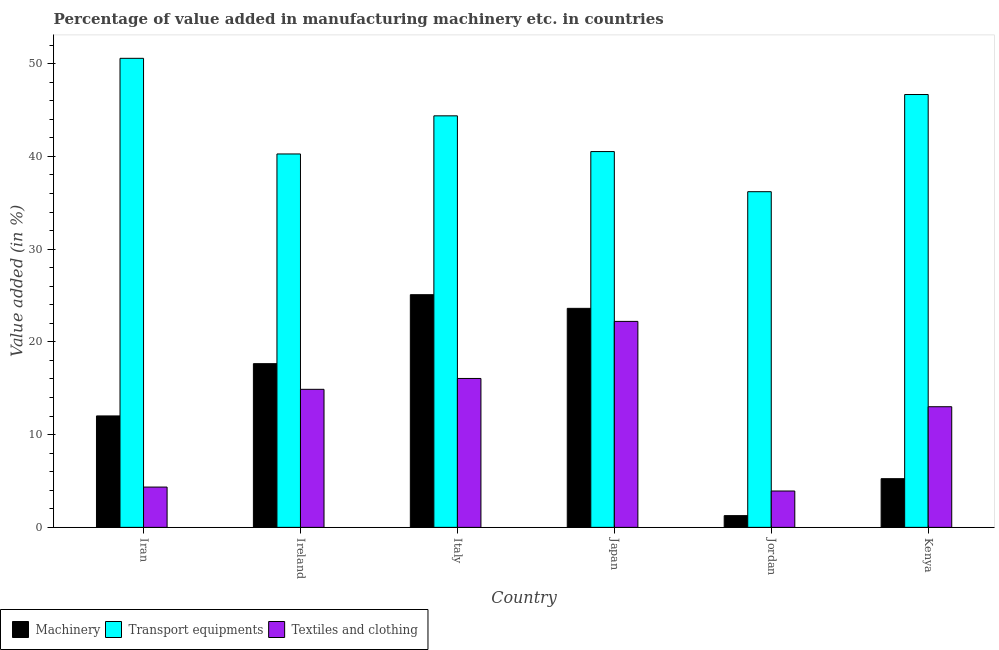How many groups of bars are there?
Give a very brief answer. 6. Are the number of bars per tick equal to the number of legend labels?
Provide a succinct answer. Yes. Are the number of bars on each tick of the X-axis equal?
Offer a terse response. Yes. What is the label of the 6th group of bars from the left?
Keep it short and to the point. Kenya. In how many cases, is the number of bars for a given country not equal to the number of legend labels?
Make the answer very short. 0. What is the value added in manufacturing textile and clothing in Kenya?
Make the answer very short. 13.01. Across all countries, what is the maximum value added in manufacturing transport equipments?
Offer a very short reply. 50.57. Across all countries, what is the minimum value added in manufacturing textile and clothing?
Give a very brief answer. 3.92. In which country was the value added in manufacturing machinery minimum?
Offer a very short reply. Jordan. What is the total value added in manufacturing textile and clothing in the graph?
Offer a terse response. 74.42. What is the difference between the value added in manufacturing machinery in Japan and that in Kenya?
Ensure brevity in your answer.  18.37. What is the difference between the value added in manufacturing machinery in Kenya and the value added in manufacturing transport equipments in Italy?
Provide a short and direct response. -39.12. What is the average value added in manufacturing transport equipments per country?
Provide a succinct answer. 43.1. What is the difference between the value added in manufacturing machinery and value added in manufacturing textile and clothing in Ireland?
Offer a very short reply. 2.77. In how many countries, is the value added in manufacturing machinery greater than 40 %?
Offer a terse response. 0. What is the ratio of the value added in manufacturing textile and clothing in Ireland to that in Kenya?
Give a very brief answer. 1.14. Is the difference between the value added in manufacturing transport equipments in Ireland and Jordan greater than the difference between the value added in manufacturing machinery in Ireland and Jordan?
Your response must be concise. No. What is the difference between the highest and the second highest value added in manufacturing machinery?
Your response must be concise. 1.47. What is the difference between the highest and the lowest value added in manufacturing machinery?
Provide a succinct answer. 23.82. In how many countries, is the value added in manufacturing machinery greater than the average value added in manufacturing machinery taken over all countries?
Provide a short and direct response. 3. Is the sum of the value added in manufacturing machinery in Ireland and Italy greater than the maximum value added in manufacturing transport equipments across all countries?
Provide a short and direct response. No. What does the 2nd bar from the left in Italy represents?
Your answer should be very brief. Transport equipments. What does the 1st bar from the right in Italy represents?
Offer a very short reply. Textiles and clothing. Is it the case that in every country, the sum of the value added in manufacturing machinery and value added in manufacturing transport equipments is greater than the value added in manufacturing textile and clothing?
Ensure brevity in your answer.  Yes. Are all the bars in the graph horizontal?
Ensure brevity in your answer.  No. How many countries are there in the graph?
Your answer should be very brief. 6. What is the difference between two consecutive major ticks on the Y-axis?
Offer a terse response. 10. Are the values on the major ticks of Y-axis written in scientific E-notation?
Your response must be concise. No. Does the graph contain any zero values?
Make the answer very short. No. Where does the legend appear in the graph?
Ensure brevity in your answer.  Bottom left. How many legend labels are there?
Make the answer very short. 3. How are the legend labels stacked?
Keep it short and to the point. Horizontal. What is the title of the graph?
Offer a terse response. Percentage of value added in manufacturing machinery etc. in countries. Does "Food" appear as one of the legend labels in the graph?
Your response must be concise. No. What is the label or title of the X-axis?
Offer a terse response. Country. What is the label or title of the Y-axis?
Your answer should be very brief. Value added (in %). What is the Value added (in %) of Machinery in Iran?
Offer a terse response. 12.01. What is the Value added (in %) of Transport equipments in Iran?
Make the answer very short. 50.57. What is the Value added (in %) of Textiles and clothing in Iran?
Ensure brevity in your answer.  4.34. What is the Value added (in %) in Machinery in Ireland?
Your answer should be compact. 17.65. What is the Value added (in %) of Transport equipments in Ireland?
Keep it short and to the point. 40.26. What is the Value added (in %) in Textiles and clothing in Ireland?
Give a very brief answer. 14.88. What is the Value added (in %) of Machinery in Italy?
Your answer should be very brief. 25.09. What is the Value added (in %) of Transport equipments in Italy?
Your answer should be very brief. 44.37. What is the Value added (in %) in Textiles and clothing in Italy?
Offer a terse response. 16.06. What is the Value added (in %) in Machinery in Japan?
Your answer should be compact. 23.61. What is the Value added (in %) of Transport equipments in Japan?
Your answer should be compact. 40.52. What is the Value added (in %) in Textiles and clothing in Japan?
Offer a terse response. 22.21. What is the Value added (in %) of Machinery in Jordan?
Your answer should be compact. 1.26. What is the Value added (in %) in Transport equipments in Jordan?
Provide a short and direct response. 36.19. What is the Value added (in %) of Textiles and clothing in Jordan?
Ensure brevity in your answer.  3.92. What is the Value added (in %) of Machinery in Kenya?
Your answer should be very brief. 5.25. What is the Value added (in %) in Transport equipments in Kenya?
Your answer should be very brief. 46.67. What is the Value added (in %) of Textiles and clothing in Kenya?
Keep it short and to the point. 13.01. Across all countries, what is the maximum Value added (in %) in Machinery?
Provide a short and direct response. 25.09. Across all countries, what is the maximum Value added (in %) of Transport equipments?
Make the answer very short. 50.57. Across all countries, what is the maximum Value added (in %) in Textiles and clothing?
Your answer should be very brief. 22.21. Across all countries, what is the minimum Value added (in %) in Machinery?
Ensure brevity in your answer.  1.26. Across all countries, what is the minimum Value added (in %) in Transport equipments?
Provide a short and direct response. 36.19. Across all countries, what is the minimum Value added (in %) in Textiles and clothing?
Your answer should be very brief. 3.92. What is the total Value added (in %) of Machinery in the graph?
Keep it short and to the point. 84.88. What is the total Value added (in %) in Transport equipments in the graph?
Provide a short and direct response. 258.59. What is the total Value added (in %) of Textiles and clothing in the graph?
Ensure brevity in your answer.  74.42. What is the difference between the Value added (in %) in Machinery in Iran and that in Ireland?
Ensure brevity in your answer.  -5.64. What is the difference between the Value added (in %) of Transport equipments in Iran and that in Ireland?
Provide a succinct answer. 10.31. What is the difference between the Value added (in %) in Textiles and clothing in Iran and that in Ireland?
Provide a short and direct response. -10.54. What is the difference between the Value added (in %) in Machinery in Iran and that in Italy?
Ensure brevity in your answer.  -13.07. What is the difference between the Value added (in %) of Transport equipments in Iran and that in Italy?
Offer a terse response. 6.2. What is the difference between the Value added (in %) of Textiles and clothing in Iran and that in Italy?
Provide a succinct answer. -11.71. What is the difference between the Value added (in %) of Machinery in Iran and that in Japan?
Ensure brevity in your answer.  -11.6. What is the difference between the Value added (in %) of Transport equipments in Iran and that in Japan?
Your answer should be very brief. 10.05. What is the difference between the Value added (in %) in Textiles and clothing in Iran and that in Japan?
Offer a terse response. -17.86. What is the difference between the Value added (in %) in Machinery in Iran and that in Jordan?
Your response must be concise. 10.75. What is the difference between the Value added (in %) in Transport equipments in Iran and that in Jordan?
Your response must be concise. 14.38. What is the difference between the Value added (in %) in Textiles and clothing in Iran and that in Jordan?
Your answer should be very brief. 0.42. What is the difference between the Value added (in %) of Machinery in Iran and that in Kenya?
Offer a very short reply. 6.77. What is the difference between the Value added (in %) of Transport equipments in Iran and that in Kenya?
Ensure brevity in your answer.  3.9. What is the difference between the Value added (in %) in Textiles and clothing in Iran and that in Kenya?
Provide a short and direct response. -8.66. What is the difference between the Value added (in %) of Machinery in Ireland and that in Italy?
Give a very brief answer. -7.44. What is the difference between the Value added (in %) in Transport equipments in Ireland and that in Italy?
Your answer should be compact. -4.11. What is the difference between the Value added (in %) in Textiles and clothing in Ireland and that in Italy?
Offer a very short reply. -1.17. What is the difference between the Value added (in %) of Machinery in Ireland and that in Japan?
Ensure brevity in your answer.  -5.96. What is the difference between the Value added (in %) in Transport equipments in Ireland and that in Japan?
Provide a short and direct response. -0.26. What is the difference between the Value added (in %) of Textiles and clothing in Ireland and that in Japan?
Offer a very short reply. -7.32. What is the difference between the Value added (in %) of Machinery in Ireland and that in Jordan?
Your answer should be very brief. 16.39. What is the difference between the Value added (in %) of Transport equipments in Ireland and that in Jordan?
Provide a succinct answer. 4.07. What is the difference between the Value added (in %) of Textiles and clothing in Ireland and that in Jordan?
Make the answer very short. 10.97. What is the difference between the Value added (in %) of Machinery in Ireland and that in Kenya?
Offer a very short reply. 12.4. What is the difference between the Value added (in %) of Transport equipments in Ireland and that in Kenya?
Provide a short and direct response. -6.41. What is the difference between the Value added (in %) in Textiles and clothing in Ireland and that in Kenya?
Offer a terse response. 1.88. What is the difference between the Value added (in %) of Machinery in Italy and that in Japan?
Make the answer very short. 1.47. What is the difference between the Value added (in %) in Transport equipments in Italy and that in Japan?
Provide a succinct answer. 3.85. What is the difference between the Value added (in %) in Textiles and clothing in Italy and that in Japan?
Provide a short and direct response. -6.15. What is the difference between the Value added (in %) in Machinery in Italy and that in Jordan?
Provide a short and direct response. 23.82. What is the difference between the Value added (in %) in Transport equipments in Italy and that in Jordan?
Keep it short and to the point. 8.18. What is the difference between the Value added (in %) in Textiles and clothing in Italy and that in Jordan?
Provide a short and direct response. 12.14. What is the difference between the Value added (in %) of Machinery in Italy and that in Kenya?
Your answer should be compact. 19.84. What is the difference between the Value added (in %) of Transport equipments in Italy and that in Kenya?
Provide a short and direct response. -2.3. What is the difference between the Value added (in %) in Textiles and clothing in Italy and that in Kenya?
Your answer should be compact. 3.05. What is the difference between the Value added (in %) of Machinery in Japan and that in Jordan?
Offer a terse response. 22.35. What is the difference between the Value added (in %) in Transport equipments in Japan and that in Jordan?
Give a very brief answer. 4.33. What is the difference between the Value added (in %) in Textiles and clothing in Japan and that in Jordan?
Give a very brief answer. 18.29. What is the difference between the Value added (in %) in Machinery in Japan and that in Kenya?
Offer a very short reply. 18.37. What is the difference between the Value added (in %) of Transport equipments in Japan and that in Kenya?
Make the answer very short. -6.15. What is the difference between the Value added (in %) of Textiles and clothing in Japan and that in Kenya?
Your response must be concise. 9.2. What is the difference between the Value added (in %) in Machinery in Jordan and that in Kenya?
Offer a terse response. -3.98. What is the difference between the Value added (in %) of Transport equipments in Jordan and that in Kenya?
Give a very brief answer. -10.48. What is the difference between the Value added (in %) in Textiles and clothing in Jordan and that in Kenya?
Give a very brief answer. -9.09. What is the difference between the Value added (in %) in Machinery in Iran and the Value added (in %) in Transport equipments in Ireland?
Your answer should be very brief. -28.25. What is the difference between the Value added (in %) of Machinery in Iran and the Value added (in %) of Textiles and clothing in Ireland?
Provide a succinct answer. -2.87. What is the difference between the Value added (in %) in Transport equipments in Iran and the Value added (in %) in Textiles and clothing in Ireland?
Provide a succinct answer. 35.69. What is the difference between the Value added (in %) of Machinery in Iran and the Value added (in %) of Transport equipments in Italy?
Your answer should be very brief. -32.36. What is the difference between the Value added (in %) in Machinery in Iran and the Value added (in %) in Textiles and clothing in Italy?
Provide a short and direct response. -4.04. What is the difference between the Value added (in %) of Transport equipments in Iran and the Value added (in %) of Textiles and clothing in Italy?
Your response must be concise. 34.52. What is the difference between the Value added (in %) of Machinery in Iran and the Value added (in %) of Transport equipments in Japan?
Ensure brevity in your answer.  -28.5. What is the difference between the Value added (in %) in Machinery in Iran and the Value added (in %) in Textiles and clothing in Japan?
Ensure brevity in your answer.  -10.19. What is the difference between the Value added (in %) of Transport equipments in Iran and the Value added (in %) of Textiles and clothing in Japan?
Your answer should be very brief. 28.37. What is the difference between the Value added (in %) in Machinery in Iran and the Value added (in %) in Transport equipments in Jordan?
Make the answer very short. -24.18. What is the difference between the Value added (in %) in Machinery in Iran and the Value added (in %) in Textiles and clothing in Jordan?
Your response must be concise. 8.1. What is the difference between the Value added (in %) in Transport equipments in Iran and the Value added (in %) in Textiles and clothing in Jordan?
Offer a very short reply. 46.65. What is the difference between the Value added (in %) of Machinery in Iran and the Value added (in %) of Transport equipments in Kenya?
Offer a terse response. -34.66. What is the difference between the Value added (in %) of Machinery in Iran and the Value added (in %) of Textiles and clothing in Kenya?
Make the answer very short. -0.99. What is the difference between the Value added (in %) in Transport equipments in Iran and the Value added (in %) in Textiles and clothing in Kenya?
Make the answer very short. 37.57. What is the difference between the Value added (in %) in Machinery in Ireland and the Value added (in %) in Transport equipments in Italy?
Your answer should be very brief. -26.72. What is the difference between the Value added (in %) in Machinery in Ireland and the Value added (in %) in Textiles and clothing in Italy?
Ensure brevity in your answer.  1.59. What is the difference between the Value added (in %) of Transport equipments in Ireland and the Value added (in %) of Textiles and clothing in Italy?
Keep it short and to the point. 24.21. What is the difference between the Value added (in %) in Machinery in Ireland and the Value added (in %) in Transport equipments in Japan?
Keep it short and to the point. -22.87. What is the difference between the Value added (in %) in Machinery in Ireland and the Value added (in %) in Textiles and clothing in Japan?
Give a very brief answer. -4.56. What is the difference between the Value added (in %) of Transport equipments in Ireland and the Value added (in %) of Textiles and clothing in Japan?
Your answer should be compact. 18.05. What is the difference between the Value added (in %) of Machinery in Ireland and the Value added (in %) of Transport equipments in Jordan?
Provide a short and direct response. -18.54. What is the difference between the Value added (in %) of Machinery in Ireland and the Value added (in %) of Textiles and clothing in Jordan?
Your answer should be very brief. 13.73. What is the difference between the Value added (in %) in Transport equipments in Ireland and the Value added (in %) in Textiles and clothing in Jordan?
Give a very brief answer. 36.34. What is the difference between the Value added (in %) of Machinery in Ireland and the Value added (in %) of Transport equipments in Kenya?
Offer a terse response. -29.02. What is the difference between the Value added (in %) of Machinery in Ireland and the Value added (in %) of Textiles and clothing in Kenya?
Provide a succinct answer. 4.64. What is the difference between the Value added (in %) in Transport equipments in Ireland and the Value added (in %) in Textiles and clothing in Kenya?
Provide a succinct answer. 27.25. What is the difference between the Value added (in %) of Machinery in Italy and the Value added (in %) of Transport equipments in Japan?
Give a very brief answer. -15.43. What is the difference between the Value added (in %) of Machinery in Italy and the Value added (in %) of Textiles and clothing in Japan?
Your answer should be very brief. 2.88. What is the difference between the Value added (in %) in Transport equipments in Italy and the Value added (in %) in Textiles and clothing in Japan?
Offer a terse response. 22.17. What is the difference between the Value added (in %) in Machinery in Italy and the Value added (in %) in Transport equipments in Jordan?
Provide a short and direct response. -11.11. What is the difference between the Value added (in %) of Machinery in Italy and the Value added (in %) of Textiles and clothing in Jordan?
Offer a terse response. 21.17. What is the difference between the Value added (in %) of Transport equipments in Italy and the Value added (in %) of Textiles and clothing in Jordan?
Make the answer very short. 40.45. What is the difference between the Value added (in %) of Machinery in Italy and the Value added (in %) of Transport equipments in Kenya?
Offer a very short reply. -21.58. What is the difference between the Value added (in %) of Machinery in Italy and the Value added (in %) of Textiles and clothing in Kenya?
Ensure brevity in your answer.  12.08. What is the difference between the Value added (in %) in Transport equipments in Italy and the Value added (in %) in Textiles and clothing in Kenya?
Give a very brief answer. 31.36. What is the difference between the Value added (in %) of Machinery in Japan and the Value added (in %) of Transport equipments in Jordan?
Keep it short and to the point. -12.58. What is the difference between the Value added (in %) of Machinery in Japan and the Value added (in %) of Textiles and clothing in Jordan?
Your response must be concise. 19.7. What is the difference between the Value added (in %) of Transport equipments in Japan and the Value added (in %) of Textiles and clothing in Jordan?
Provide a short and direct response. 36.6. What is the difference between the Value added (in %) of Machinery in Japan and the Value added (in %) of Transport equipments in Kenya?
Your response must be concise. -23.06. What is the difference between the Value added (in %) of Machinery in Japan and the Value added (in %) of Textiles and clothing in Kenya?
Offer a terse response. 10.61. What is the difference between the Value added (in %) of Transport equipments in Japan and the Value added (in %) of Textiles and clothing in Kenya?
Ensure brevity in your answer.  27.51. What is the difference between the Value added (in %) of Machinery in Jordan and the Value added (in %) of Transport equipments in Kenya?
Provide a short and direct response. -45.41. What is the difference between the Value added (in %) of Machinery in Jordan and the Value added (in %) of Textiles and clothing in Kenya?
Your answer should be compact. -11.74. What is the difference between the Value added (in %) in Transport equipments in Jordan and the Value added (in %) in Textiles and clothing in Kenya?
Provide a succinct answer. 23.19. What is the average Value added (in %) in Machinery per country?
Your answer should be very brief. 14.15. What is the average Value added (in %) of Transport equipments per country?
Give a very brief answer. 43.1. What is the average Value added (in %) in Textiles and clothing per country?
Provide a succinct answer. 12.4. What is the difference between the Value added (in %) in Machinery and Value added (in %) in Transport equipments in Iran?
Offer a very short reply. -38.56. What is the difference between the Value added (in %) in Machinery and Value added (in %) in Textiles and clothing in Iran?
Your answer should be very brief. 7.67. What is the difference between the Value added (in %) of Transport equipments and Value added (in %) of Textiles and clothing in Iran?
Offer a terse response. 46.23. What is the difference between the Value added (in %) of Machinery and Value added (in %) of Transport equipments in Ireland?
Your response must be concise. -22.61. What is the difference between the Value added (in %) of Machinery and Value added (in %) of Textiles and clothing in Ireland?
Your answer should be compact. 2.77. What is the difference between the Value added (in %) in Transport equipments and Value added (in %) in Textiles and clothing in Ireland?
Give a very brief answer. 25.38. What is the difference between the Value added (in %) in Machinery and Value added (in %) in Transport equipments in Italy?
Provide a short and direct response. -19.29. What is the difference between the Value added (in %) in Machinery and Value added (in %) in Textiles and clothing in Italy?
Provide a succinct answer. 9.03. What is the difference between the Value added (in %) in Transport equipments and Value added (in %) in Textiles and clothing in Italy?
Make the answer very short. 28.32. What is the difference between the Value added (in %) in Machinery and Value added (in %) in Transport equipments in Japan?
Offer a terse response. -16.9. What is the difference between the Value added (in %) in Machinery and Value added (in %) in Textiles and clothing in Japan?
Keep it short and to the point. 1.41. What is the difference between the Value added (in %) of Transport equipments and Value added (in %) of Textiles and clothing in Japan?
Give a very brief answer. 18.31. What is the difference between the Value added (in %) in Machinery and Value added (in %) in Transport equipments in Jordan?
Keep it short and to the point. -34.93. What is the difference between the Value added (in %) in Machinery and Value added (in %) in Textiles and clothing in Jordan?
Your answer should be very brief. -2.66. What is the difference between the Value added (in %) of Transport equipments and Value added (in %) of Textiles and clothing in Jordan?
Your answer should be compact. 32.27. What is the difference between the Value added (in %) of Machinery and Value added (in %) of Transport equipments in Kenya?
Provide a short and direct response. -41.42. What is the difference between the Value added (in %) in Machinery and Value added (in %) in Textiles and clothing in Kenya?
Offer a very short reply. -7.76. What is the difference between the Value added (in %) of Transport equipments and Value added (in %) of Textiles and clothing in Kenya?
Your answer should be compact. 33.66. What is the ratio of the Value added (in %) in Machinery in Iran to that in Ireland?
Make the answer very short. 0.68. What is the ratio of the Value added (in %) in Transport equipments in Iran to that in Ireland?
Offer a very short reply. 1.26. What is the ratio of the Value added (in %) in Textiles and clothing in Iran to that in Ireland?
Give a very brief answer. 0.29. What is the ratio of the Value added (in %) in Machinery in Iran to that in Italy?
Offer a terse response. 0.48. What is the ratio of the Value added (in %) in Transport equipments in Iran to that in Italy?
Give a very brief answer. 1.14. What is the ratio of the Value added (in %) in Textiles and clothing in Iran to that in Italy?
Keep it short and to the point. 0.27. What is the ratio of the Value added (in %) in Machinery in Iran to that in Japan?
Your answer should be very brief. 0.51. What is the ratio of the Value added (in %) in Transport equipments in Iran to that in Japan?
Your answer should be very brief. 1.25. What is the ratio of the Value added (in %) in Textiles and clothing in Iran to that in Japan?
Offer a terse response. 0.2. What is the ratio of the Value added (in %) of Machinery in Iran to that in Jordan?
Ensure brevity in your answer.  9.51. What is the ratio of the Value added (in %) of Transport equipments in Iran to that in Jordan?
Your answer should be compact. 1.4. What is the ratio of the Value added (in %) of Textiles and clothing in Iran to that in Jordan?
Keep it short and to the point. 1.11. What is the ratio of the Value added (in %) of Machinery in Iran to that in Kenya?
Keep it short and to the point. 2.29. What is the ratio of the Value added (in %) in Transport equipments in Iran to that in Kenya?
Your answer should be compact. 1.08. What is the ratio of the Value added (in %) of Textiles and clothing in Iran to that in Kenya?
Offer a very short reply. 0.33. What is the ratio of the Value added (in %) of Machinery in Ireland to that in Italy?
Give a very brief answer. 0.7. What is the ratio of the Value added (in %) of Transport equipments in Ireland to that in Italy?
Your answer should be compact. 0.91. What is the ratio of the Value added (in %) in Textiles and clothing in Ireland to that in Italy?
Keep it short and to the point. 0.93. What is the ratio of the Value added (in %) of Machinery in Ireland to that in Japan?
Ensure brevity in your answer.  0.75. What is the ratio of the Value added (in %) in Transport equipments in Ireland to that in Japan?
Offer a very short reply. 0.99. What is the ratio of the Value added (in %) of Textiles and clothing in Ireland to that in Japan?
Make the answer very short. 0.67. What is the ratio of the Value added (in %) in Machinery in Ireland to that in Jordan?
Offer a terse response. 13.96. What is the ratio of the Value added (in %) of Transport equipments in Ireland to that in Jordan?
Your answer should be very brief. 1.11. What is the ratio of the Value added (in %) of Textiles and clothing in Ireland to that in Jordan?
Your response must be concise. 3.8. What is the ratio of the Value added (in %) in Machinery in Ireland to that in Kenya?
Offer a terse response. 3.36. What is the ratio of the Value added (in %) of Transport equipments in Ireland to that in Kenya?
Your answer should be very brief. 0.86. What is the ratio of the Value added (in %) in Textiles and clothing in Ireland to that in Kenya?
Keep it short and to the point. 1.14. What is the ratio of the Value added (in %) of Machinery in Italy to that in Japan?
Keep it short and to the point. 1.06. What is the ratio of the Value added (in %) in Transport equipments in Italy to that in Japan?
Keep it short and to the point. 1.1. What is the ratio of the Value added (in %) of Textiles and clothing in Italy to that in Japan?
Make the answer very short. 0.72. What is the ratio of the Value added (in %) of Machinery in Italy to that in Jordan?
Make the answer very short. 19.85. What is the ratio of the Value added (in %) in Transport equipments in Italy to that in Jordan?
Keep it short and to the point. 1.23. What is the ratio of the Value added (in %) in Textiles and clothing in Italy to that in Jordan?
Your answer should be compact. 4.1. What is the ratio of the Value added (in %) in Machinery in Italy to that in Kenya?
Offer a terse response. 4.78. What is the ratio of the Value added (in %) in Transport equipments in Italy to that in Kenya?
Ensure brevity in your answer.  0.95. What is the ratio of the Value added (in %) in Textiles and clothing in Italy to that in Kenya?
Keep it short and to the point. 1.23. What is the ratio of the Value added (in %) of Machinery in Japan to that in Jordan?
Offer a very short reply. 18.68. What is the ratio of the Value added (in %) in Transport equipments in Japan to that in Jordan?
Ensure brevity in your answer.  1.12. What is the ratio of the Value added (in %) of Textiles and clothing in Japan to that in Jordan?
Your answer should be very brief. 5.67. What is the ratio of the Value added (in %) in Machinery in Japan to that in Kenya?
Offer a terse response. 4.5. What is the ratio of the Value added (in %) in Transport equipments in Japan to that in Kenya?
Make the answer very short. 0.87. What is the ratio of the Value added (in %) of Textiles and clothing in Japan to that in Kenya?
Give a very brief answer. 1.71. What is the ratio of the Value added (in %) of Machinery in Jordan to that in Kenya?
Your response must be concise. 0.24. What is the ratio of the Value added (in %) in Transport equipments in Jordan to that in Kenya?
Provide a short and direct response. 0.78. What is the ratio of the Value added (in %) in Textiles and clothing in Jordan to that in Kenya?
Offer a terse response. 0.3. What is the difference between the highest and the second highest Value added (in %) in Machinery?
Offer a very short reply. 1.47. What is the difference between the highest and the second highest Value added (in %) of Transport equipments?
Your answer should be very brief. 3.9. What is the difference between the highest and the second highest Value added (in %) in Textiles and clothing?
Provide a succinct answer. 6.15. What is the difference between the highest and the lowest Value added (in %) in Machinery?
Your answer should be very brief. 23.82. What is the difference between the highest and the lowest Value added (in %) in Transport equipments?
Offer a very short reply. 14.38. What is the difference between the highest and the lowest Value added (in %) in Textiles and clothing?
Your answer should be compact. 18.29. 